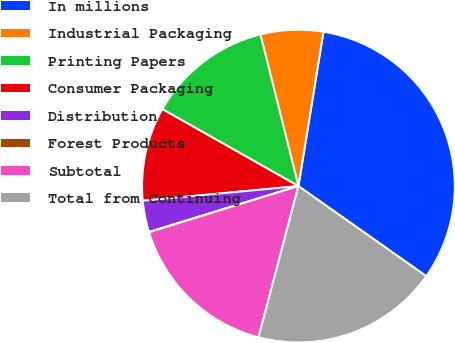Convert chart to OTSL. <chart><loc_0><loc_0><loc_500><loc_500><pie_chart><fcel>In millions<fcel>Industrial Packaging<fcel>Printing Papers<fcel>Consumer Packaging<fcel>Distribution<fcel>Forest Products<fcel>Subtotal<fcel>Total from Continuing<nl><fcel>32.21%<fcel>6.47%<fcel>12.9%<fcel>9.68%<fcel>3.25%<fcel>0.03%<fcel>16.12%<fcel>19.34%<nl></chart> 